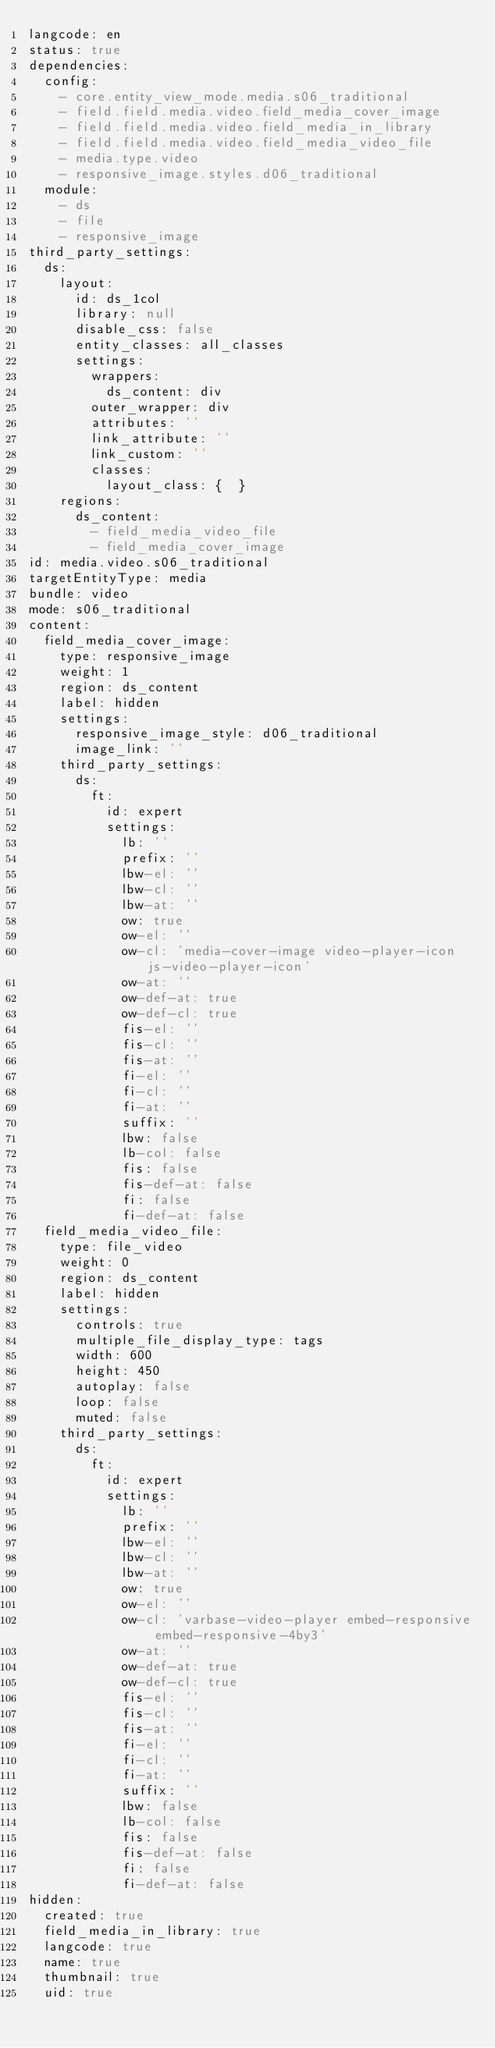Convert code to text. <code><loc_0><loc_0><loc_500><loc_500><_YAML_>langcode: en
status: true
dependencies:
  config:
    - core.entity_view_mode.media.s06_traditional
    - field.field.media.video.field_media_cover_image
    - field.field.media.video.field_media_in_library
    - field.field.media.video.field_media_video_file
    - media.type.video
    - responsive_image.styles.d06_traditional
  module:
    - ds
    - file
    - responsive_image
third_party_settings:
  ds:
    layout:
      id: ds_1col
      library: null
      disable_css: false
      entity_classes: all_classes
      settings:
        wrappers:
          ds_content: div
        outer_wrapper: div
        attributes: ''
        link_attribute: ''
        link_custom: ''
        classes:
          layout_class: {  }
    regions:
      ds_content:
        - field_media_video_file
        - field_media_cover_image
id: media.video.s06_traditional
targetEntityType: media
bundle: video
mode: s06_traditional
content:
  field_media_cover_image:
    type: responsive_image
    weight: 1
    region: ds_content
    label: hidden
    settings:
      responsive_image_style: d06_traditional
      image_link: ''
    third_party_settings:
      ds:
        ft:
          id: expert
          settings:
            lb: ''
            prefix: ''
            lbw-el: ''
            lbw-cl: ''
            lbw-at: ''
            ow: true
            ow-el: ''
            ow-cl: 'media-cover-image video-player-icon js-video-player-icon'
            ow-at: ''
            ow-def-at: true
            ow-def-cl: true
            fis-el: ''
            fis-cl: ''
            fis-at: ''
            fi-el: ''
            fi-cl: ''
            fi-at: ''
            suffix: ''
            lbw: false
            lb-col: false
            fis: false
            fis-def-at: false
            fi: false
            fi-def-at: false
  field_media_video_file:
    type: file_video
    weight: 0
    region: ds_content
    label: hidden
    settings:
      controls: true
      multiple_file_display_type: tags
      width: 600
      height: 450
      autoplay: false
      loop: false
      muted: false
    third_party_settings:
      ds:
        ft:
          id: expert
          settings:
            lb: ''
            prefix: ''
            lbw-el: ''
            lbw-cl: ''
            lbw-at: ''
            ow: true
            ow-el: ''
            ow-cl: 'varbase-video-player embed-responsive embed-responsive-4by3'
            ow-at: ''
            ow-def-at: true
            ow-def-cl: true
            fis-el: ''
            fis-cl: ''
            fis-at: ''
            fi-el: ''
            fi-cl: ''
            fi-at: ''
            suffix: ''
            lbw: false
            lb-col: false
            fis: false
            fis-def-at: false
            fi: false
            fi-def-at: false
hidden:
  created: true
  field_media_in_library: true
  langcode: true
  name: true
  thumbnail: true
  uid: true
</code> 